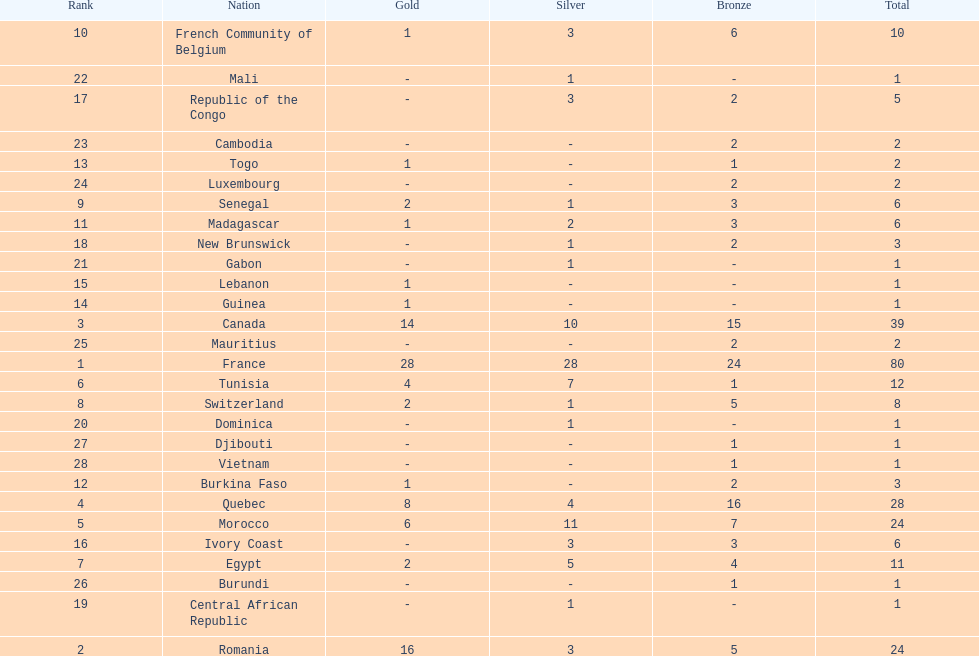What is the difference between france's and egypt's silver medals? 23. 